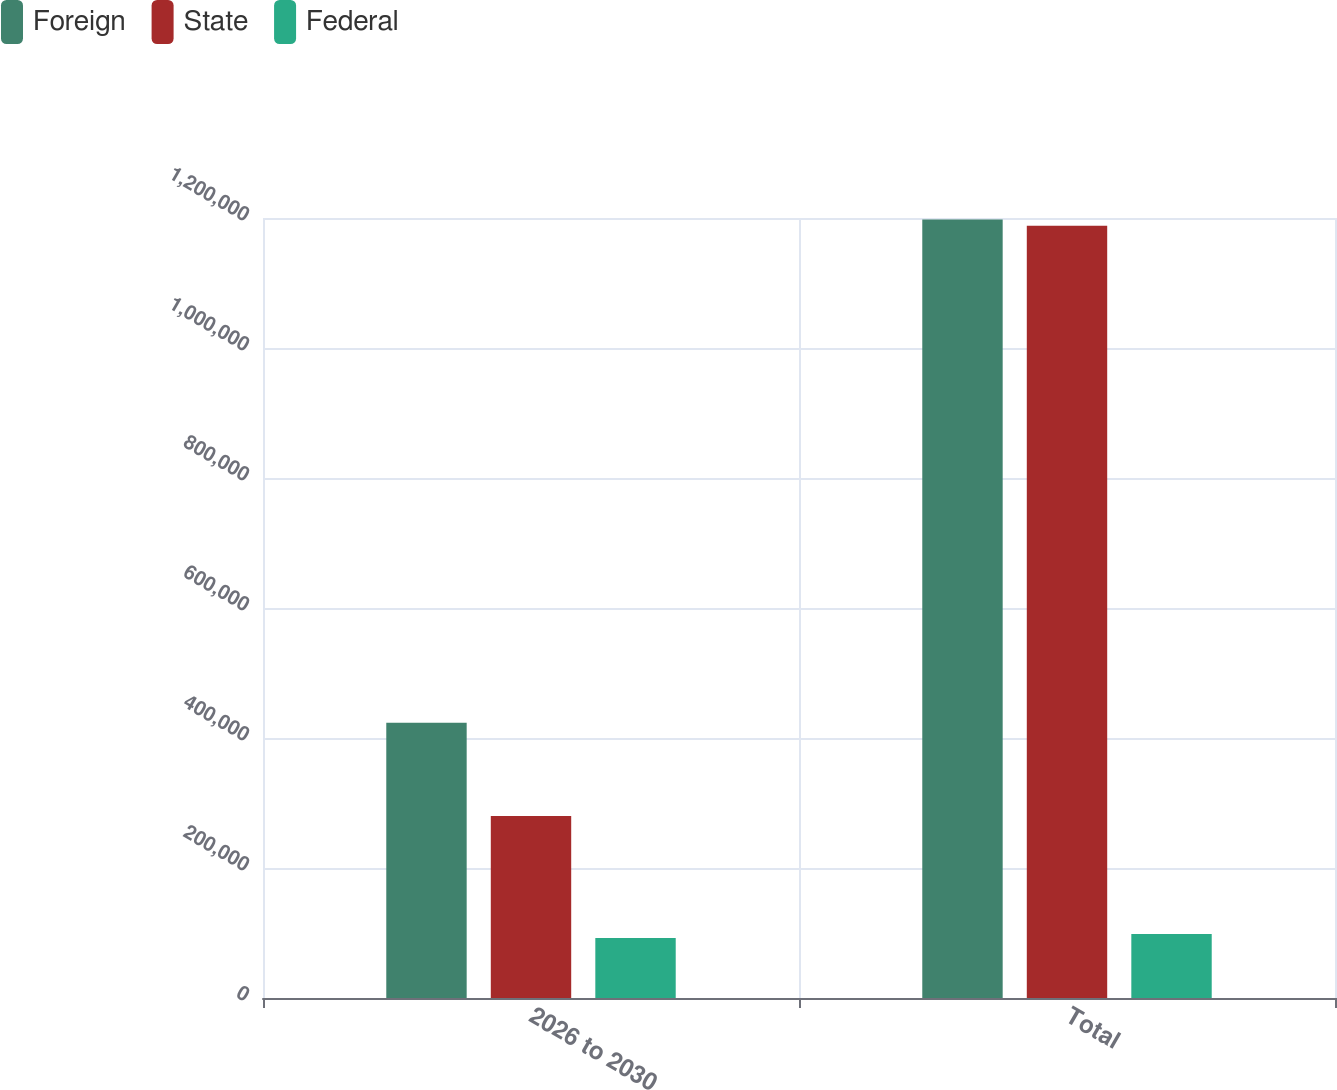Convert chart. <chart><loc_0><loc_0><loc_500><loc_500><stacked_bar_chart><ecel><fcel>2026 to 2030<fcel>Total<nl><fcel>Foreign<fcel>423398<fcel>1.19761e+06<nl><fcel>State<fcel>279908<fcel>1.188e+06<nl><fcel>Federal<fcel>92412<fcel>98424<nl></chart> 